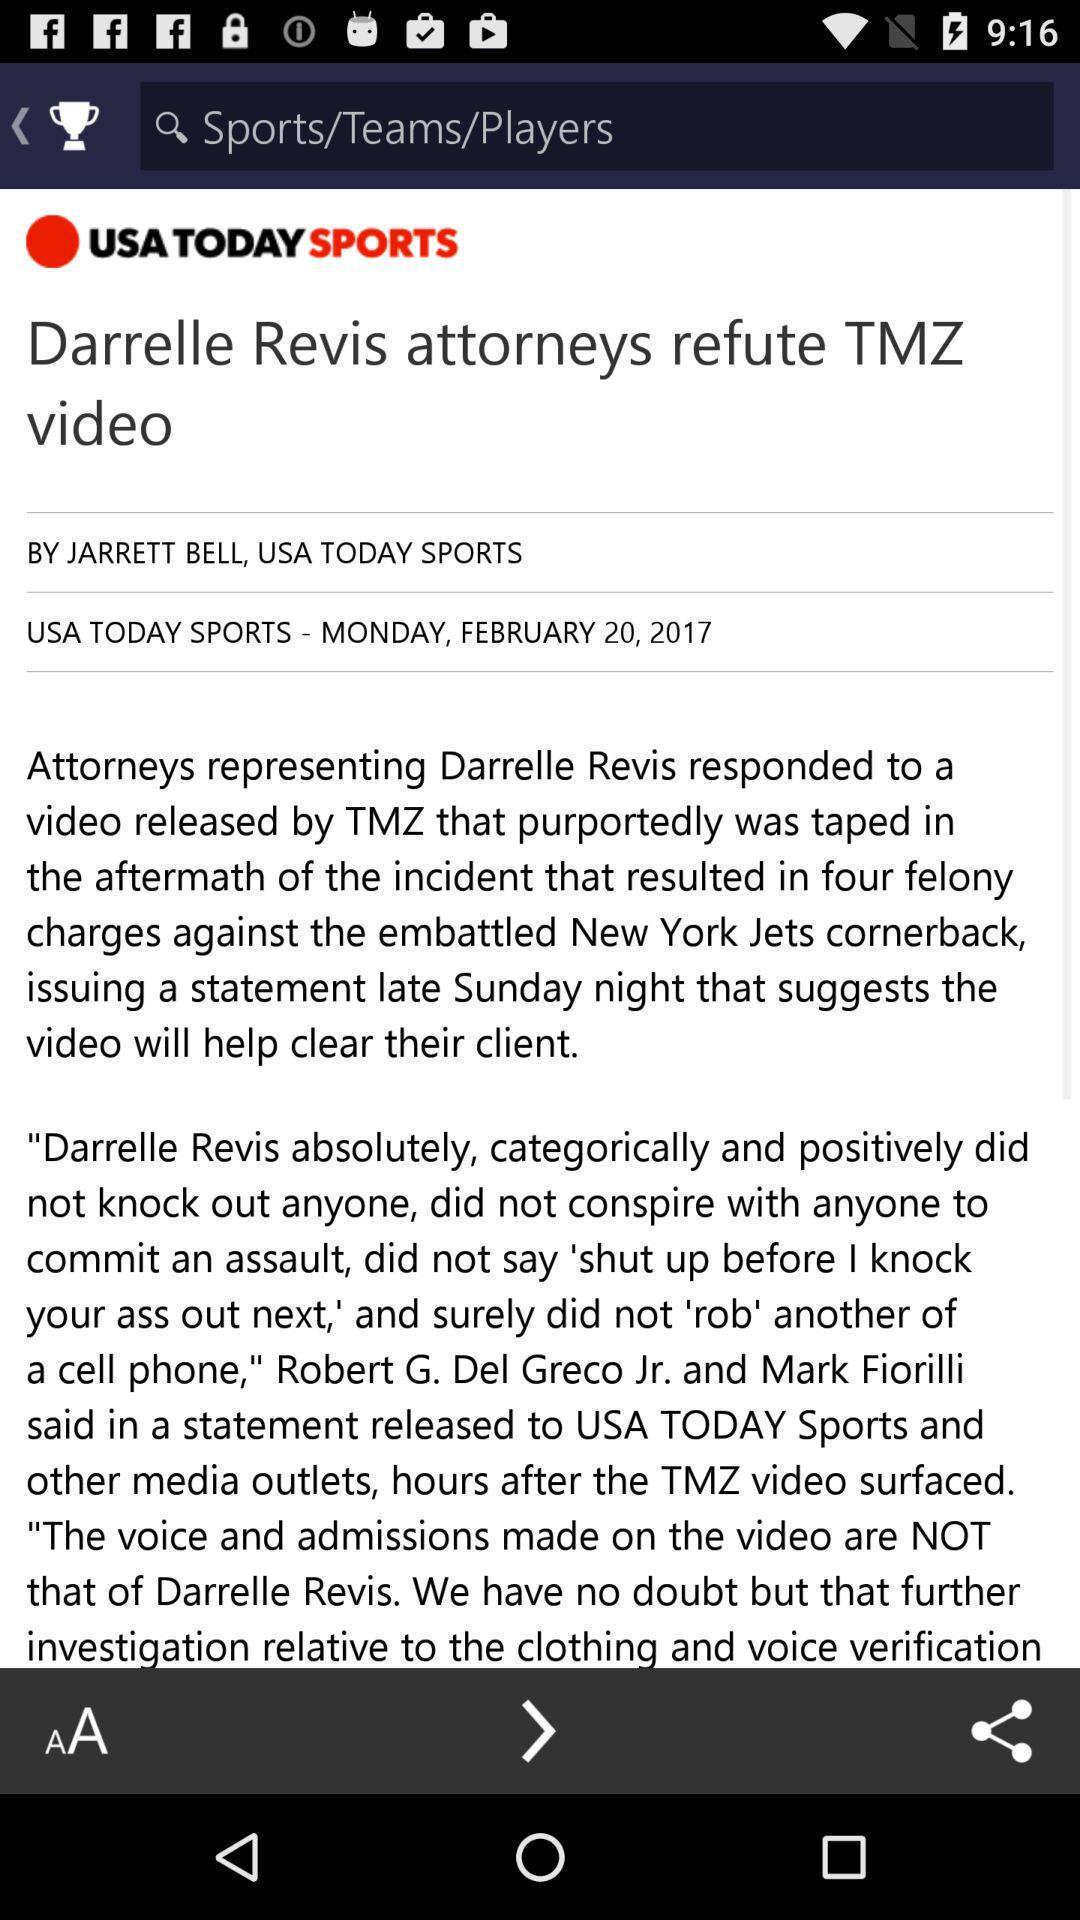What is the publication date? The date is Monday, February 20, 2017. 